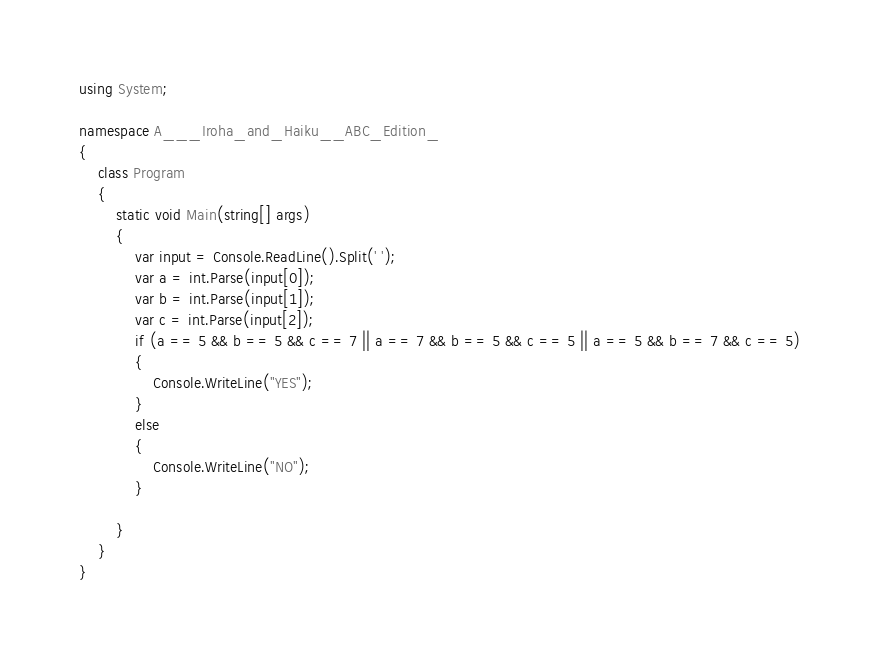<code> <loc_0><loc_0><loc_500><loc_500><_C#_>using System;

namespace A___Iroha_and_Haiku__ABC_Edition_
{
    class Program
    {
        static void Main(string[] args)
        {
            var input = Console.ReadLine().Split(' ');
            var a = int.Parse(input[0]);
            var b = int.Parse(input[1]);
            var c = int.Parse(input[2]);
            if (a == 5 && b == 5 && c == 7 || a == 7 && b == 5 && c == 5 || a == 5 && b == 7 && c == 5)
            {
                Console.WriteLine("YES");
            }
            else
            {
                Console.WriteLine("NO");
            }

        }
    }
}</code> 